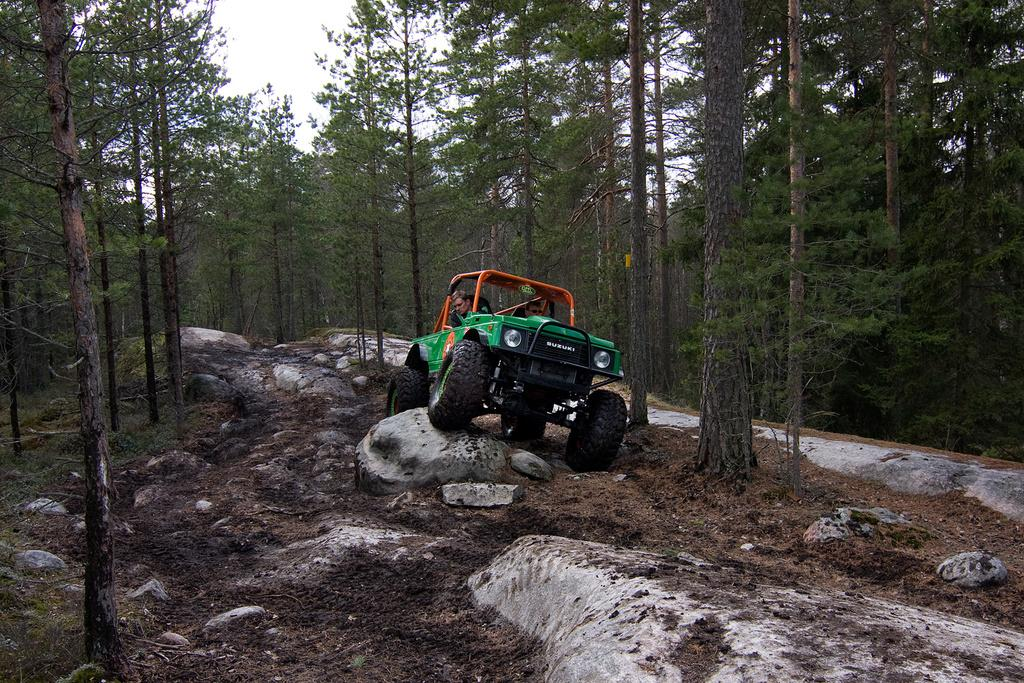How many people are in the image? There are two people in the image. What are the two people doing in the image? The two people are on a vehicle. What can be seen in the background of the image? There are rocks and trees in the background of the image. What type of brass instrument is being played by the person in the image? There is no brass instrument present in the image. What memory does the person in the image have about the rocks in the background? The image does not provide any information about the person's memories or thoughts about the rocks in the background. 